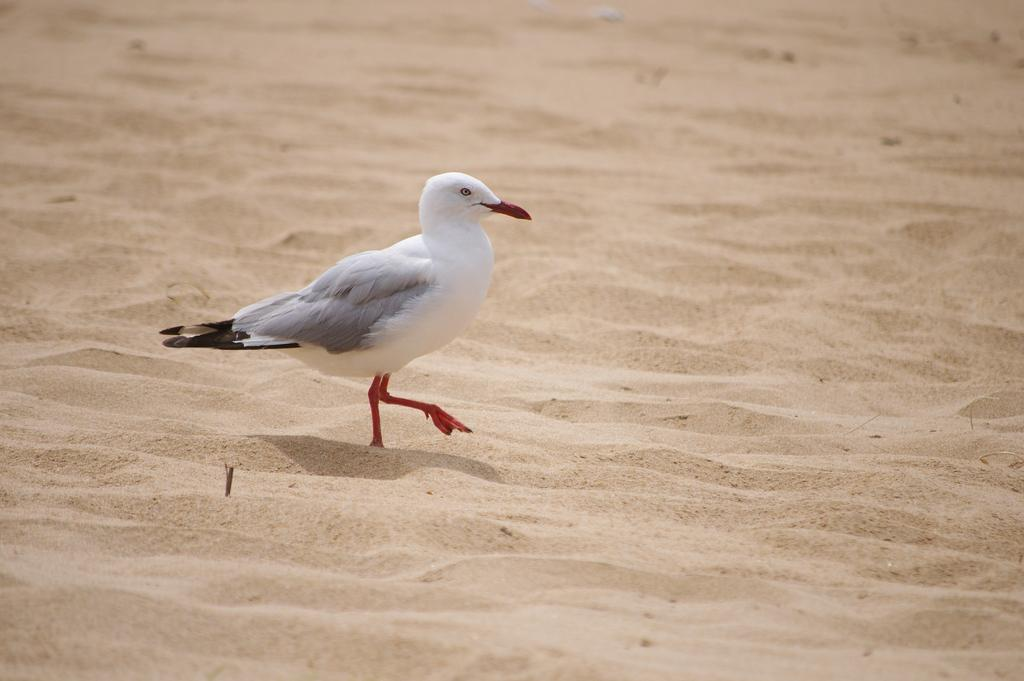What type of animal can be seen in the image? There is a bird in the image. What is the bird standing on? The bird is standing on the sand. What type of selection process is being conducted in the image? There is no selection process visible in the image; it features a bird standing on the sand. Is there a mine present in the image? There is no mine present in the image; it features a bird standing on the sand. 